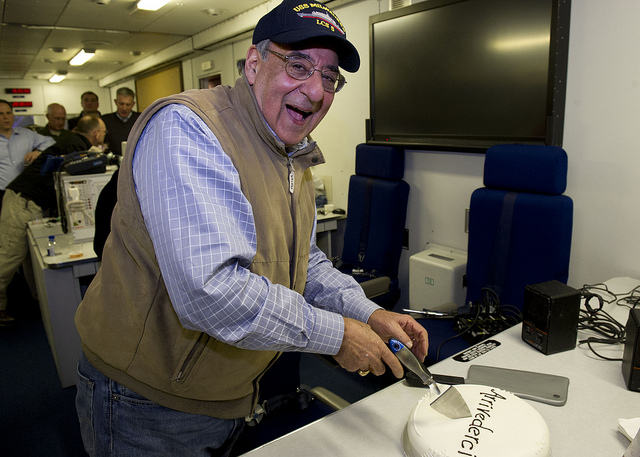Please transcribe the text information in this image. Arrivederci 